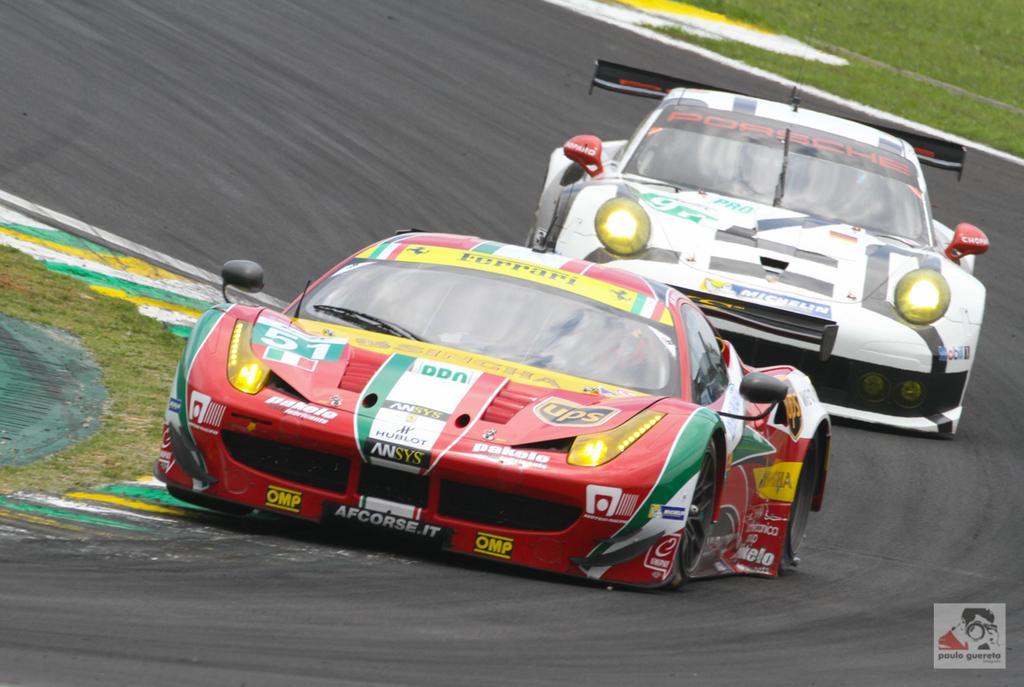In one or two sentences, can you explain what this image depicts? In this picture, we see the sports or racing cars in red and white color. At the bottom, we see the road. In the right bottom, we see the grass. On the left side, we see the grass. 